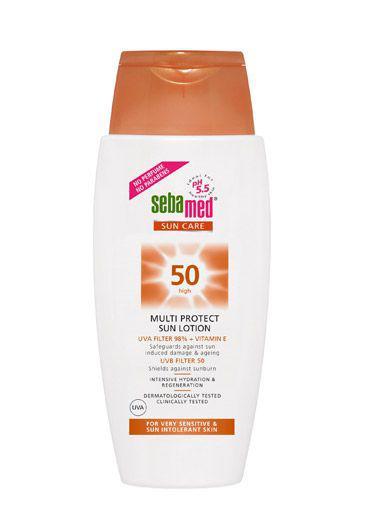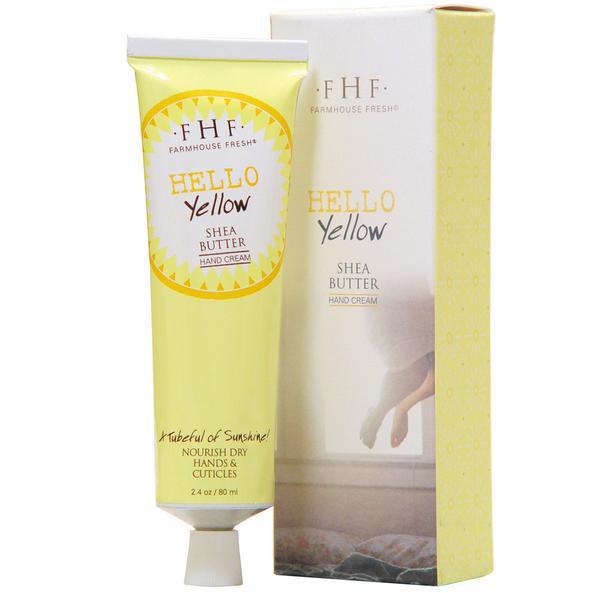The first image is the image on the left, the second image is the image on the right. Evaluate the accuracy of this statement regarding the images: "In one image, a product in a tube stands on end beside the box in which it is packaged to be sold.". Is it true? Answer yes or no. Yes. The first image is the image on the left, the second image is the image on the right. Evaluate the accuracy of this statement regarding the images: "Left image shows a product with orange top half and light bottom half.". Is it true? Answer yes or no. No. 